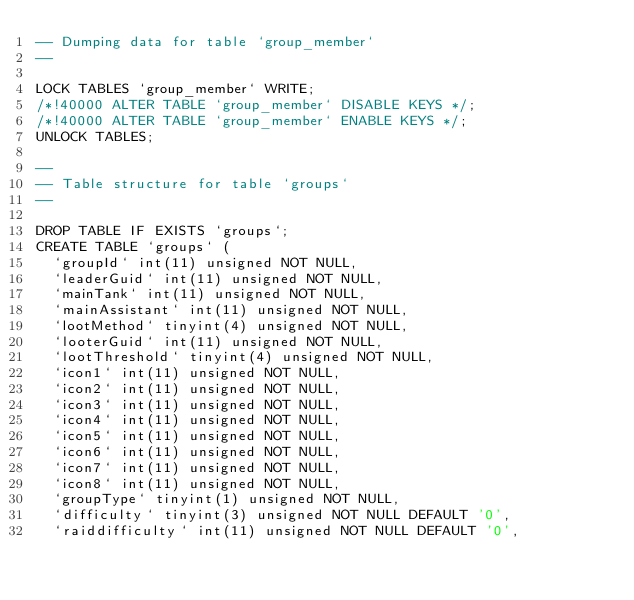<code> <loc_0><loc_0><loc_500><loc_500><_SQL_>-- Dumping data for table `group_member`
--

LOCK TABLES `group_member` WRITE;
/*!40000 ALTER TABLE `group_member` DISABLE KEYS */;
/*!40000 ALTER TABLE `group_member` ENABLE KEYS */;
UNLOCK TABLES;

--
-- Table structure for table `groups`
--

DROP TABLE IF EXISTS `groups`;
CREATE TABLE `groups` (
  `groupId` int(11) unsigned NOT NULL,
  `leaderGuid` int(11) unsigned NOT NULL,
  `mainTank` int(11) unsigned NOT NULL,
  `mainAssistant` int(11) unsigned NOT NULL,
  `lootMethod` tinyint(4) unsigned NOT NULL,
  `looterGuid` int(11) unsigned NOT NULL,
  `lootThreshold` tinyint(4) unsigned NOT NULL,
  `icon1` int(11) unsigned NOT NULL,
  `icon2` int(11) unsigned NOT NULL,
  `icon3` int(11) unsigned NOT NULL,
  `icon4` int(11) unsigned NOT NULL,
  `icon5` int(11) unsigned NOT NULL,
  `icon6` int(11) unsigned NOT NULL,
  `icon7` int(11) unsigned NOT NULL,
  `icon8` int(11) unsigned NOT NULL,
  `groupType` tinyint(1) unsigned NOT NULL,
  `difficulty` tinyint(3) unsigned NOT NULL DEFAULT '0',
  `raiddifficulty` int(11) unsigned NOT NULL DEFAULT '0',</code> 